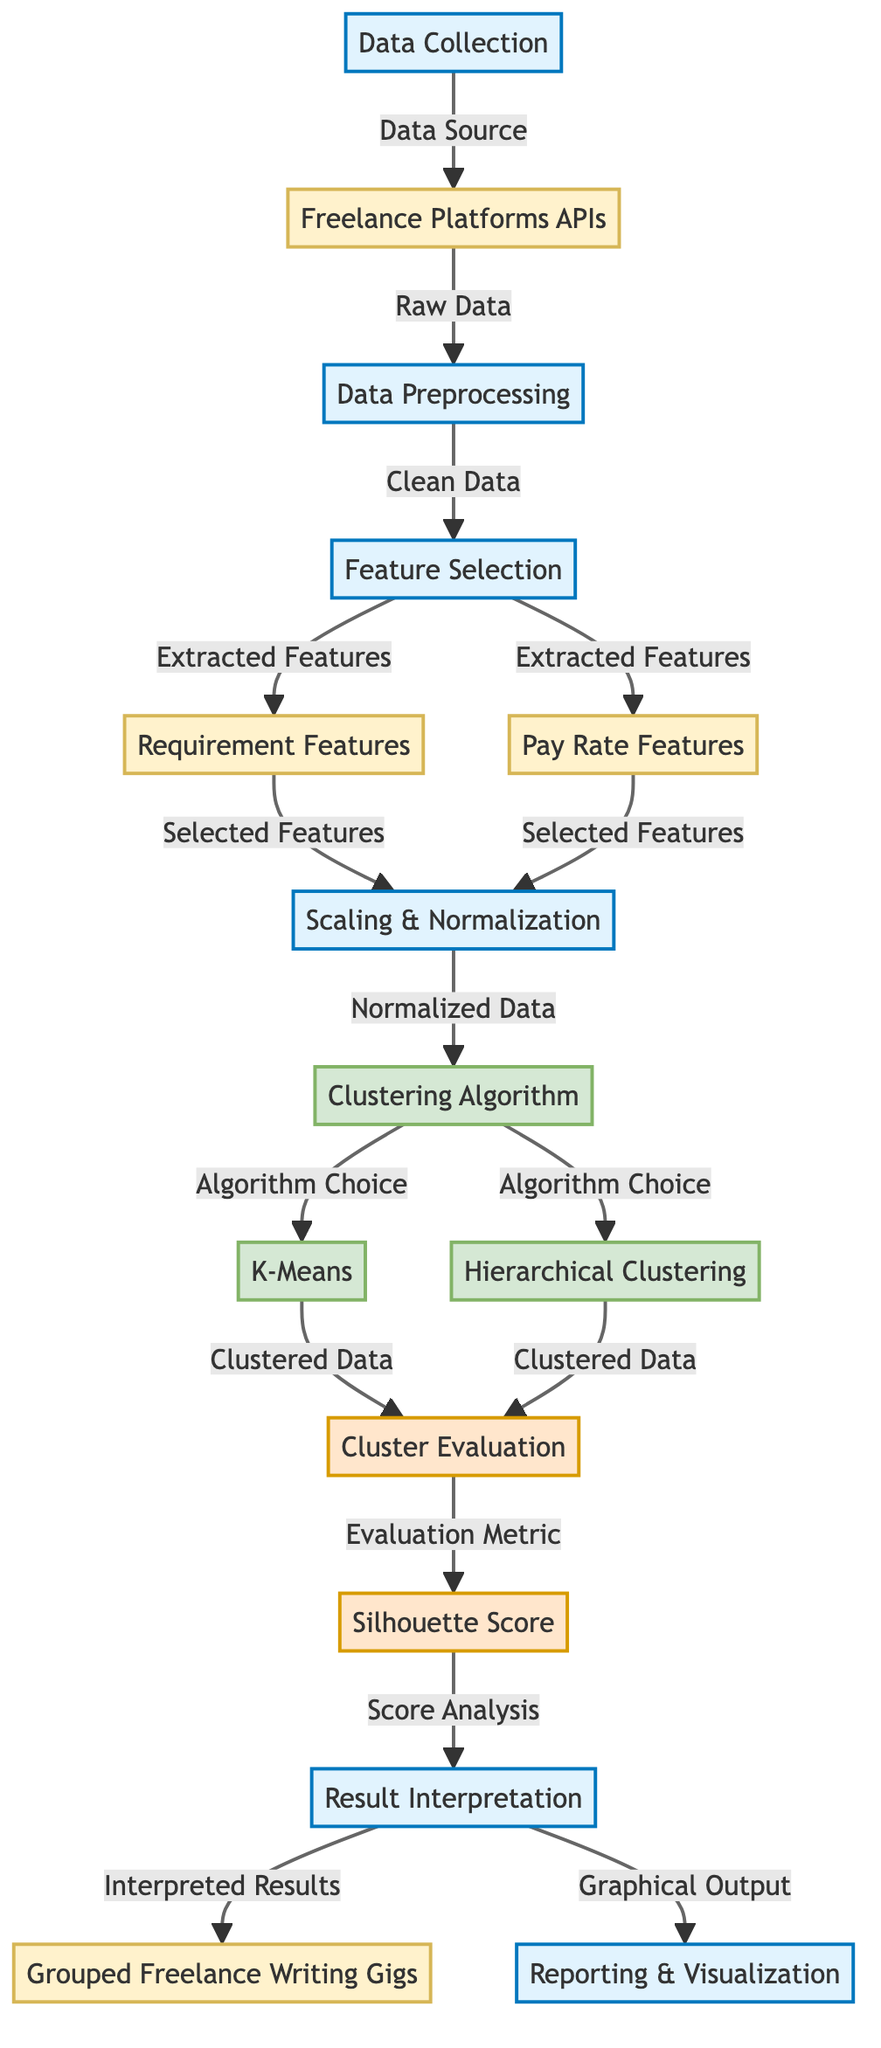What is the first step in the diagram? The first step indicated by the diagram is "Data Collection", which is connected to "Freelance Platforms APIs". This is the starting point of the process, where data related to freelance writing gigs is initially gathered.
Answer: Data Collection How many algorithms are presented in the diagram? The diagram features two clustering algorithms: "K-Means" and "Hierarchical Clustering". Both are included as choices within the "Clustering Algorithm" process node.
Answer: 2 What is the output of the "Clustering Algorithm" process? The output of the "Clustering Algorithm" process is "Clustered Data", which flows to the "Cluster Evaluation" node. This indicates that data has been processed using clustering techniques.
Answer: Clustered Data Which feature types are extracted during the "Feature Selection" step? The diagram shows two types of features extracted during the "Feature Selection" step: "Requirement Features" and "Pay Rate Features". These represent the attributes needed for clustering.
Answer: Requirement Features and Pay Rate Features What evaluation metric is used in the "Cluster Evaluation" step? The evaluation metric indicated in the diagram is the "Silhouette Score". This score helps assess the quality of clustering by measuring how similar an object is to its own cluster compared to other clusters.
Answer: Silhouette Score What follows after the "Cluster Evaluation" step? After the "Cluster Evaluation" step, the next processes are "Result Interpretation" and "Reporting & Visualization", where the results of the clustering are analyzed and visualized.
Answer: Result Interpretation and Reporting & Visualization Which step immediately follows "Pay Rate Features"? The step that immediately follows "Pay Rate Features" is "Scaling & Normalization". This indicates that pay rate features will be normalized before proceeding to clustering.
Answer: Scaling & Normalization What is the final output of the diagram? The final outputs listed in the diagram are "Grouped Freelance Writing Gigs" and "Graphical Output" from the "Result Interpretation" process, indicating both textual and visual representations of the results.
Answer: Grouped Freelance Writing Gigs and Graphical Output 